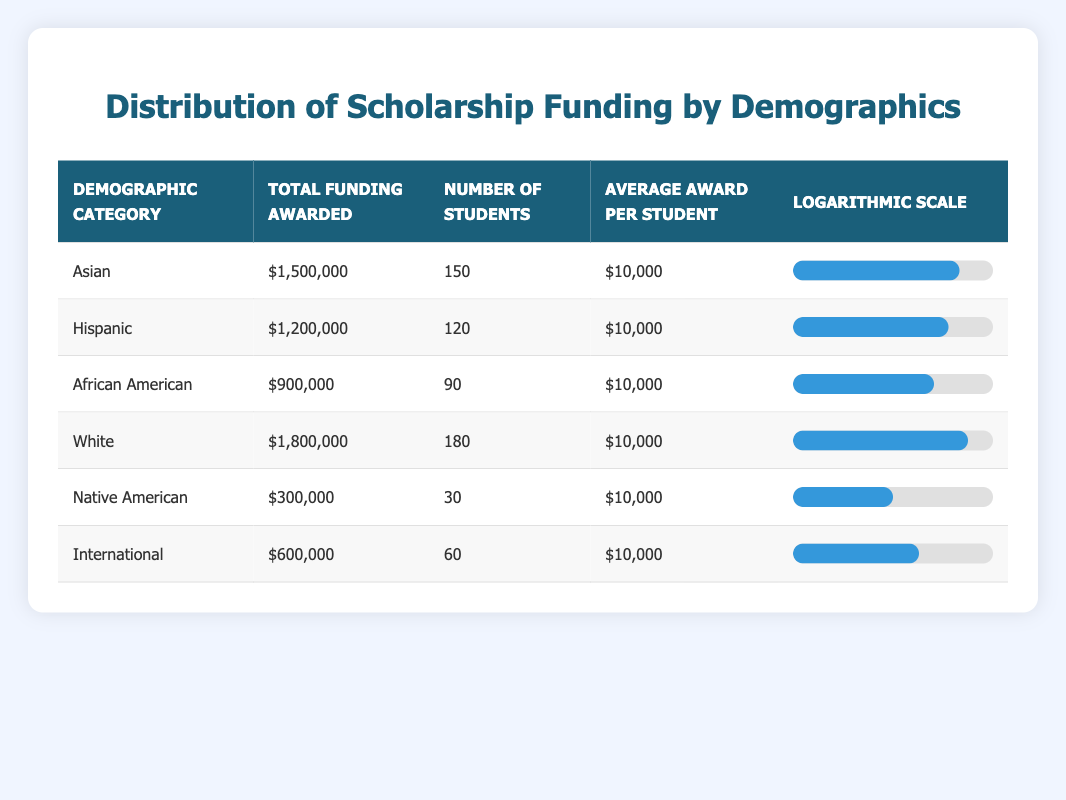What is the total funding awarded to the White demographic category? The table shows a specific row for the White demographic category, under which the total funding awarded is listed as $1,800,000.
Answer: $1,800,000 How many total students received scholarships across all demographic categories? To find the total number of students, we sum the number of students in each category: (150 + 120 + 90 + 180 + 30 + 60) = 630.
Answer: 630 Is the average award per student consistent across all demographic categories? The average award per student for each demographic listed is $10,000, indicating that every category has the same average award amount.
Answer: Yes Which demographic category received the least total funding? Looking through the total funding awarded for each category, Native American funding is the least at $300,000 compared to others.
Answer: Native American What is the difference in total funding awarded between the Asian and Hispanic demographic categories? To find the difference in total funding, we subtract the funding for Hispanic from Asian: $1,500,000 (Asian) - $1,200,000 (Hispanic) = $300,000.
Answer: $300,000 What is the average funding awarded per student for the International demographic? The average award per student for the International demographic category is $10,000, as listed in the table for that category.
Answer: $10,000 If we pool together the total funding awarded to African American and Native American students, how much funding would that total? The total funding for African American is $900,000 and for Native American is $300,000, so we add these values together: $900,000 + $300,000 = $1,200,000.
Answer: $1,200,000 Which demographic categories have total funding of at least $1,000,000? By reviewing the total funding amounts, we find that Asian, Hispanic, and White categories exceed $1,000,000, totaling $1,500,000, $1,200,000, and $1,800,000 respectively.
Answer: Asian, Hispanic, White What percentage of total students are Hispanic? The number of Hispanic students is 120, and total students are 630. The percentage is calculated as (120/630) * 100 ≈ 19.05%.
Answer: 19.05% 